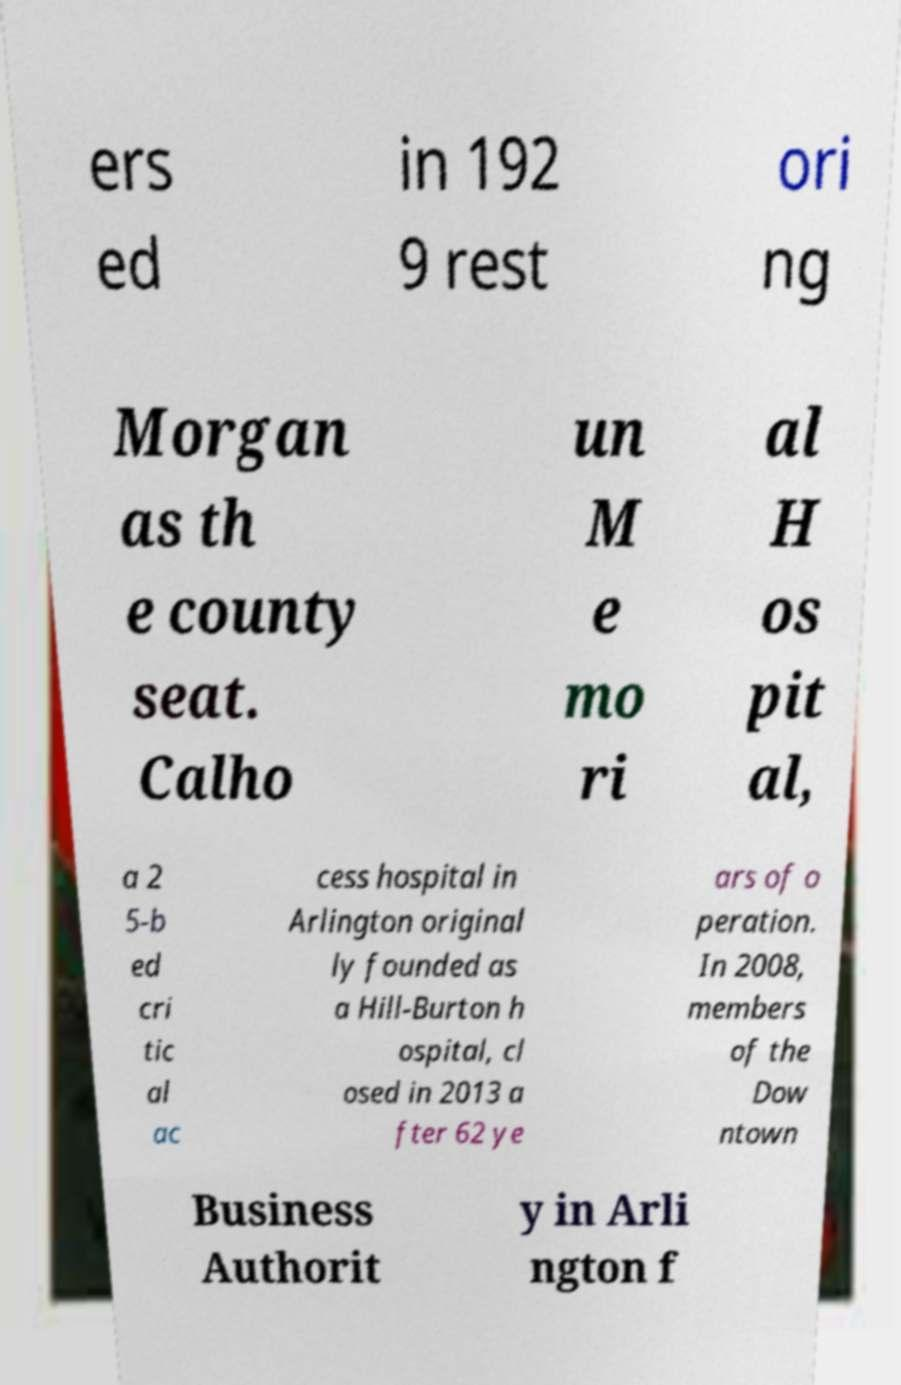Please read and relay the text visible in this image. What does it say? ers ed in 192 9 rest ori ng Morgan as th e county seat. Calho un M e mo ri al H os pit al, a 2 5-b ed cri tic al ac cess hospital in Arlington original ly founded as a Hill-Burton h ospital, cl osed in 2013 a fter 62 ye ars of o peration. In 2008, members of the Dow ntown Business Authorit y in Arli ngton f 